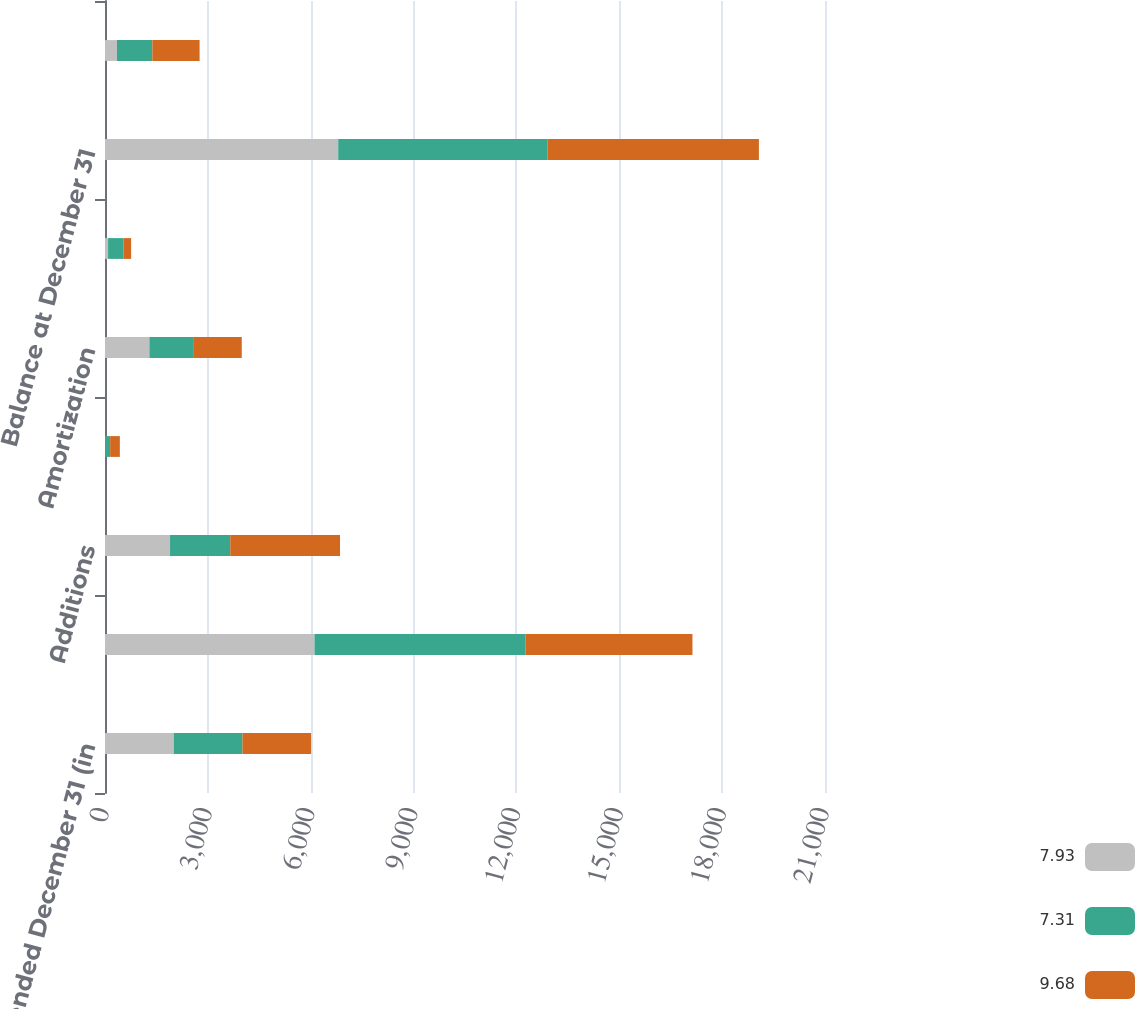<chart> <loc_0><loc_0><loc_500><loc_500><stacked_bar_chart><ecel><fcel>Year ended December 31 (in<fcel>Balance at January 1<fcel>Additions<fcel>Other-than-temporary<fcel>Amortization<fcel>SFAS 133 hedge valuation<fcel>Balance at December 31<fcel>Less valuation allowance<nl><fcel>7.93<fcel>2005<fcel>6111<fcel>1897<fcel>1<fcel>1295<fcel>90<fcel>6802<fcel>350<nl><fcel>7.31<fcel>2004<fcel>6159<fcel>1757<fcel>149<fcel>1297<fcel>446<fcel>6111<fcel>1031<nl><fcel>9.68<fcel>2003<fcel>4864<fcel>3201<fcel>283<fcel>1397<fcel>226<fcel>6159<fcel>1378<nl></chart> 